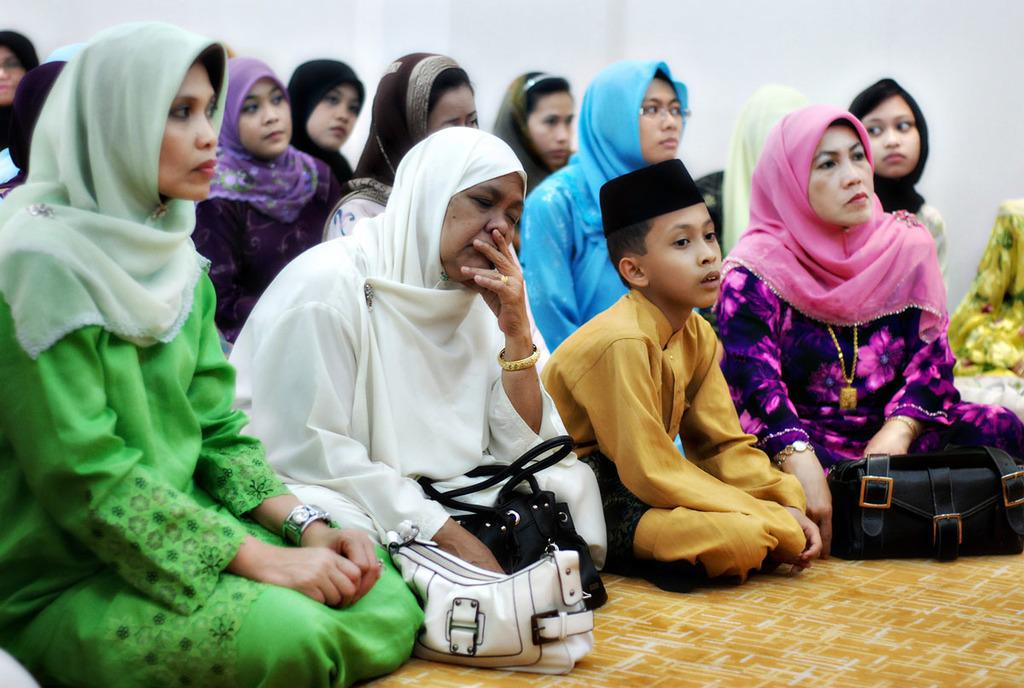What are the people in the image doing? The group of people is sitting on the floor in the image. What color is the wall in the background? The background wall is white in color. Where was the image taken? The image was taken inside a house. When was the image taken? The image was taken during day time. What type of activity is the secretary performing in the image? There is no secretary present in the image, so no such activity can be observed. 